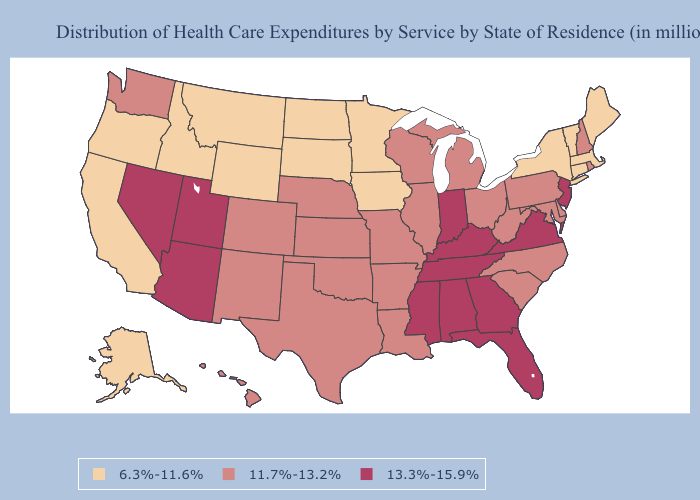Does the map have missing data?
Concise answer only. No. Name the states that have a value in the range 11.7%-13.2%?
Keep it brief. Arkansas, Colorado, Delaware, Hawaii, Illinois, Kansas, Louisiana, Maryland, Michigan, Missouri, Nebraska, New Hampshire, New Mexico, North Carolina, Ohio, Oklahoma, Pennsylvania, Rhode Island, South Carolina, Texas, Washington, West Virginia, Wisconsin. Does Mississippi have the highest value in the USA?
Answer briefly. Yes. Name the states that have a value in the range 6.3%-11.6%?
Keep it brief. Alaska, California, Connecticut, Idaho, Iowa, Maine, Massachusetts, Minnesota, Montana, New York, North Dakota, Oregon, South Dakota, Vermont, Wyoming. Name the states that have a value in the range 11.7%-13.2%?
Write a very short answer. Arkansas, Colorado, Delaware, Hawaii, Illinois, Kansas, Louisiana, Maryland, Michigan, Missouri, Nebraska, New Hampshire, New Mexico, North Carolina, Ohio, Oklahoma, Pennsylvania, Rhode Island, South Carolina, Texas, Washington, West Virginia, Wisconsin. What is the highest value in the South ?
Short answer required. 13.3%-15.9%. Does the map have missing data?
Keep it brief. No. Name the states that have a value in the range 6.3%-11.6%?
Short answer required. Alaska, California, Connecticut, Idaho, Iowa, Maine, Massachusetts, Minnesota, Montana, New York, North Dakota, Oregon, South Dakota, Vermont, Wyoming. Does West Virginia have the lowest value in the South?
Write a very short answer. Yes. What is the value of Georgia?
Quick response, please. 13.3%-15.9%. Which states hav the highest value in the West?
Concise answer only. Arizona, Nevada, Utah. What is the lowest value in the South?
Keep it brief. 11.7%-13.2%. Does the map have missing data?
Be succinct. No. What is the lowest value in the USA?
Concise answer only. 6.3%-11.6%. 